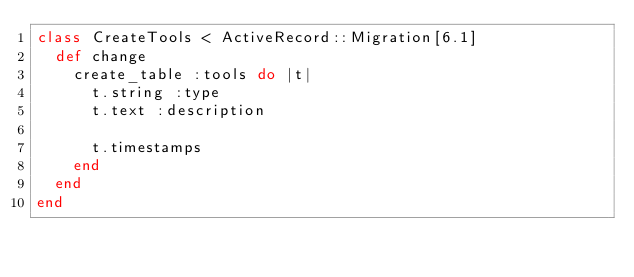<code> <loc_0><loc_0><loc_500><loc_500><_Ruby_>class CreateTools < ActiveRecord::Migration[6.1]
  def change
    create_table :tools do |t|
      t.string :type
      t.text :description

      t.timestamps
    end
  end
end
</code> 